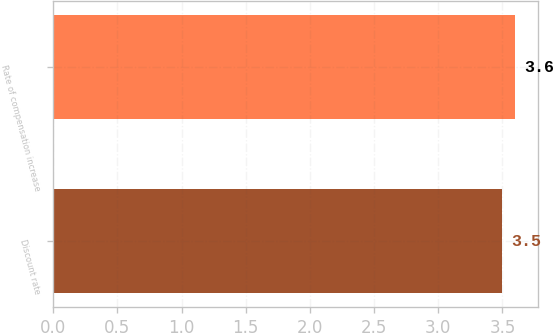Convert chart. <chart><loc_0><loc_0><loc_500><loc_500><bar_chart><fcel>Discount rate<fcel>Rate of compensation increase<nl><fcel>3.5<fcel>3.6<nl></chart> 